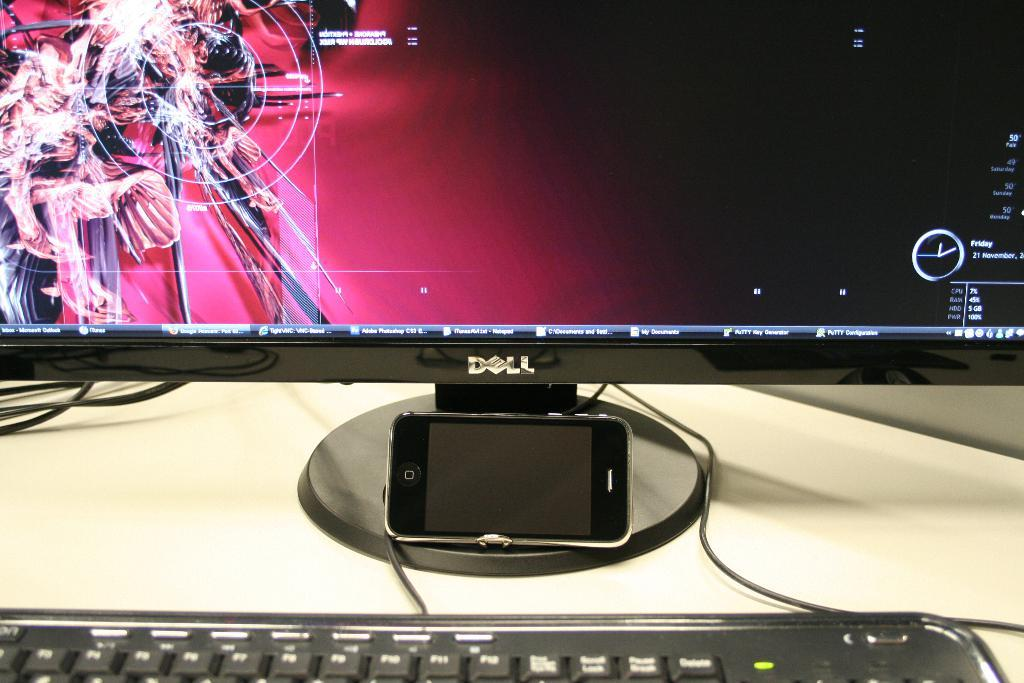<image>
Write a terse but informative summary of the picture. A dell computer showing a screen with a pink background and information and a keyboard in front of the screen. 